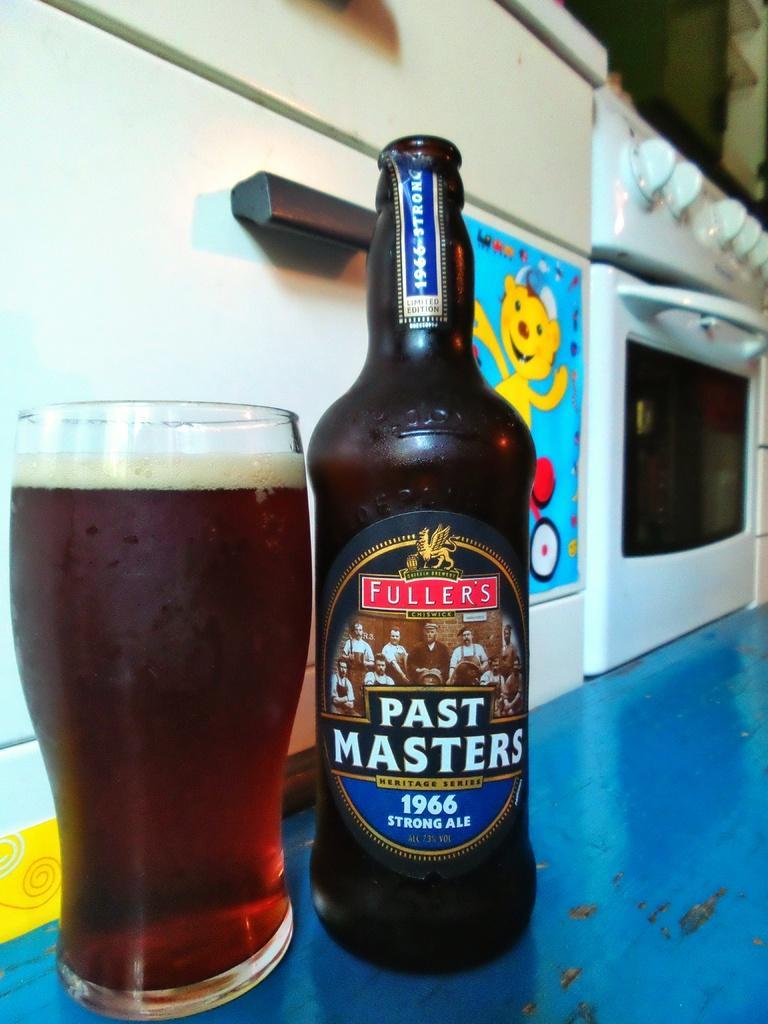Please provide a concise description of this image. Here we can see a bottle and glass with liquids. Beside this bottle and glass there are ovens. 